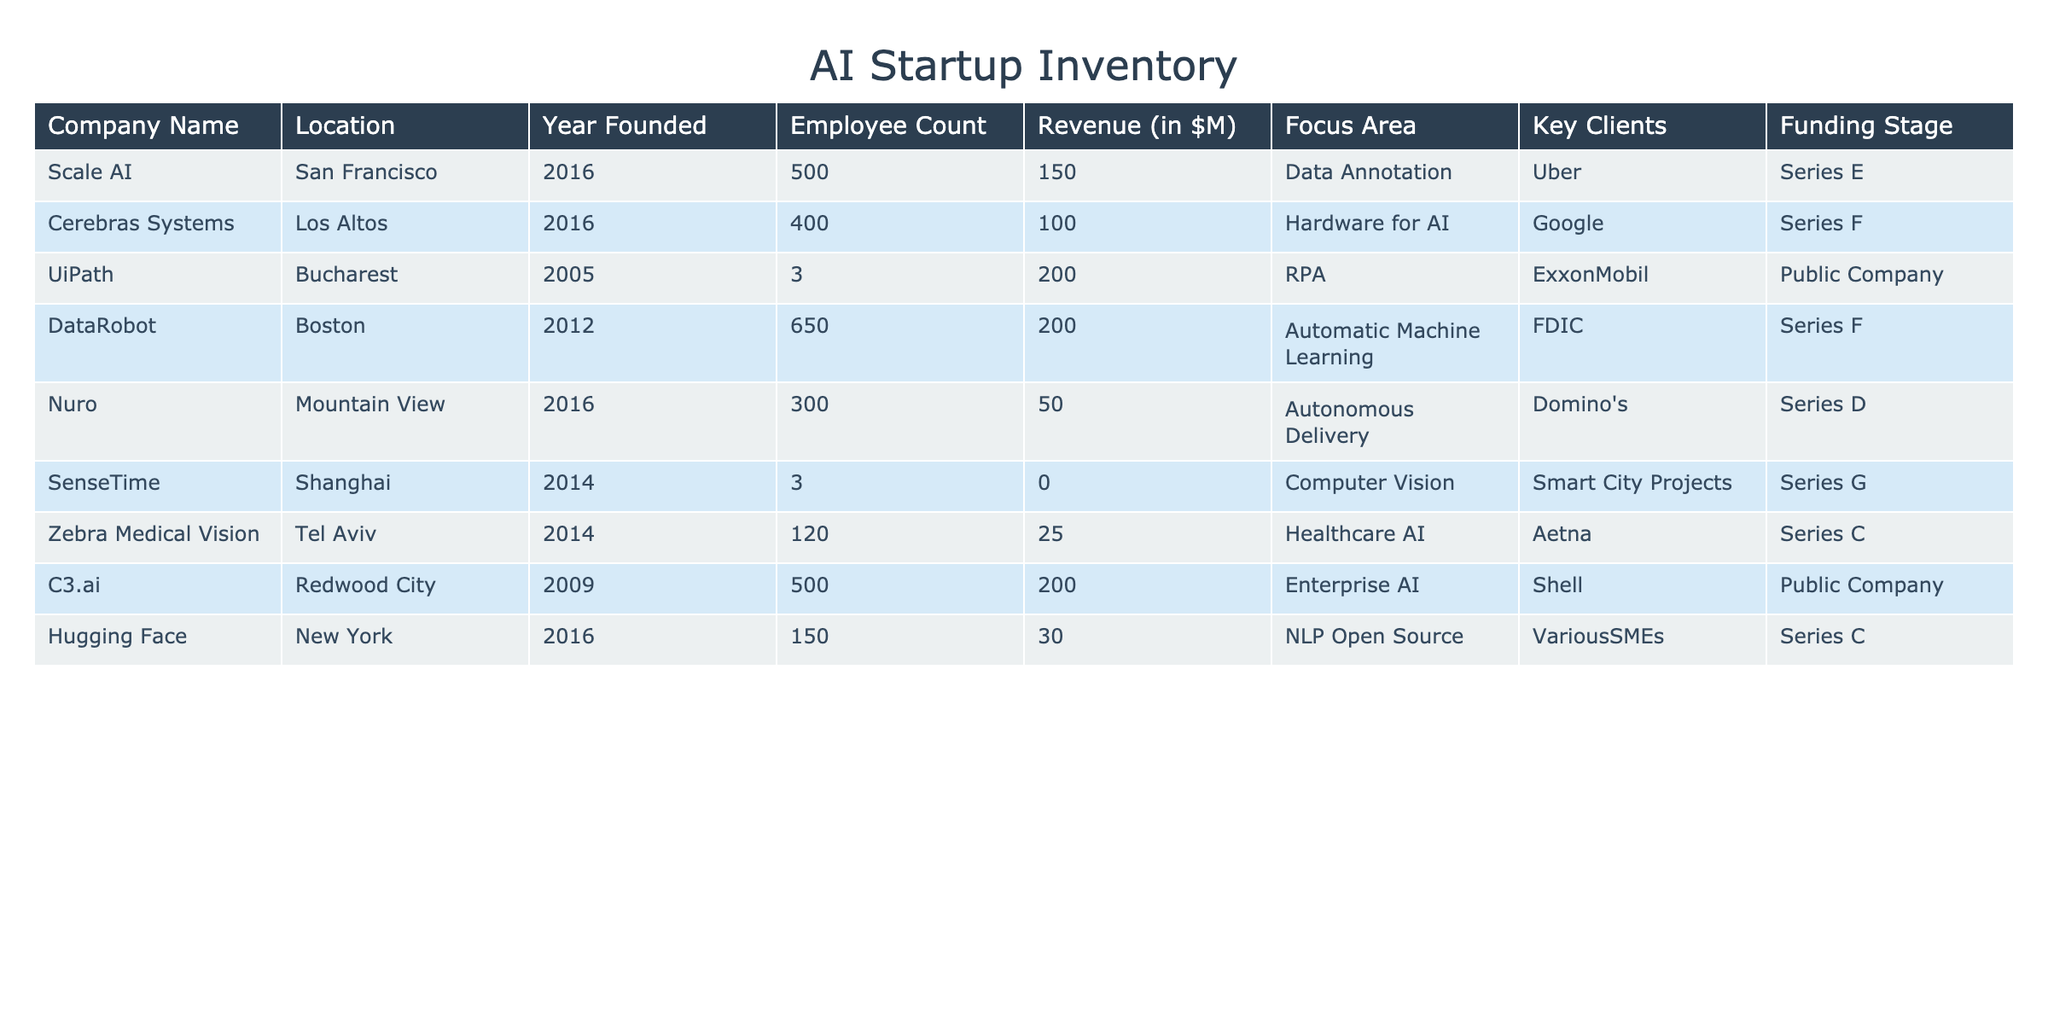What is the revenue of Scale AI? The revenue for Scale AI is listed directly in the table under the "Revenue (in $M)" column. The value next to Scale AI is 150.
Answer: 150 How many employees does DataRobot have? The number of employees for DataRobot is given in the "Employee Count" column. The value next to DataRobot is 650.
Answer: 650 Is UiPath a public company? The funding stage for UiPath is "Public Company," indicating that it is indeed a public company.
Answer: Yes Which company has the highest revenue? To find the company with the highest revenue, we need to compare the revenue values for all companies. DataRobot, UiPath, and C3.ai all have revenues above 200 million, but UiPath has the highest at 200 million by itself, while DataRobot and C3.ai both have 200 million as well. Therefore, there isn't a single highest revenue. The row for UiPath indicates 200 million, which is shared.
Answer: UiPath, DataRobot, and C3.ai What is the average employee count among companies focused on healthcare AI? From the table, there is only one company focused on healthcare AI, which is Zebra Medical Vision, with an employee count of 120. Thus, the average employee count is equal to its employee count since it is the only data point.
Answer: 120 Are there any companies founded before 2010? To answer this, we look at the "Year Founded" column and see which companies are founded in 2009 or earlier. The companies are UiPath (2005) and C3.ai (2009). Therefore, there are companies founded before 2010.
Answer: Yes What is the total revenue of all companies located in San Francisco? The companies located in San Francisco are Scale AI and DataRobot. Their revenues are 150 million and 200 million, respectively. We sum these amounts: 150 + 200 = 350 million, giving us the total revenue for these companies.
Answer: 350 Which company has the smallest employee count and what is it? To find the company with the smallest employee count, we can look through the "Employee Count" column and identify that Zebra Medical Vision has the lowest count at 120 employees.
Answer: 120 Which company has been funded at the Series G stage? By examining the "Funding Stage" column, we see that SenseTime is the only company listed with a Series G funding stage.
Answer: SenseTime 